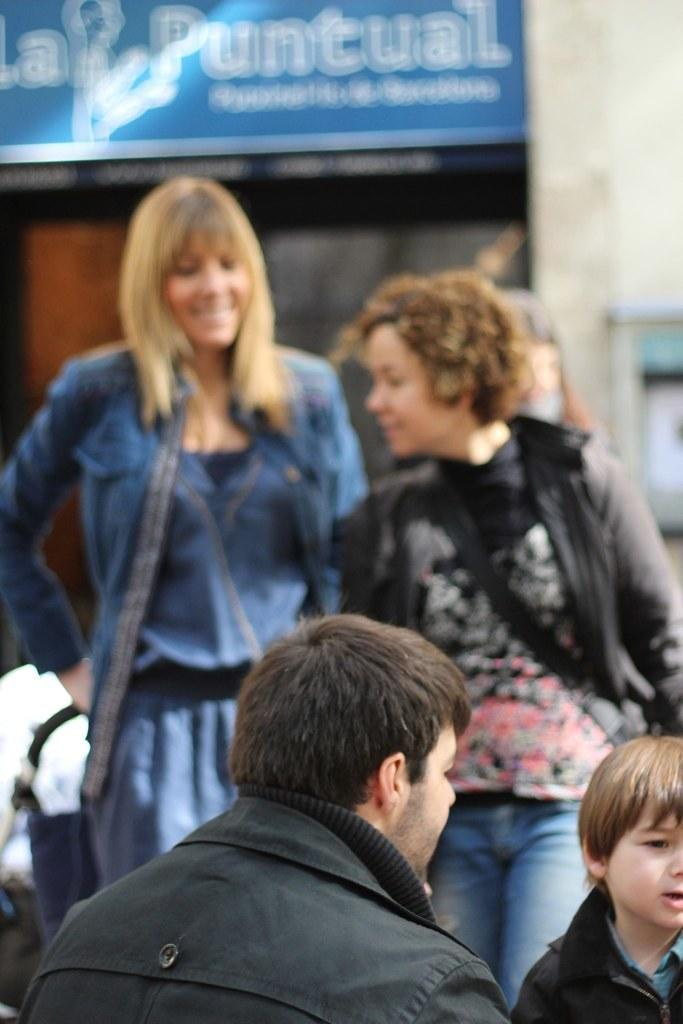Who is in the foreground of the image? There is a man in a black jacket and a boy in the foreground of the image. Where is the man located in the image? The man is at the bottom of the image. Where is the boy located in the image? The boy is in the right bottom corner of the image. What can be seen in the background of the image? There are two women, a wall, and a blue board in the background of the image. What type of dog can be seen playing with steam in the image? There is no dog or steam present in the image. How does the air interact with the blue board in the image? The image does not show any interaction between the air and the blue board; it only shows the board's presence in the background. 